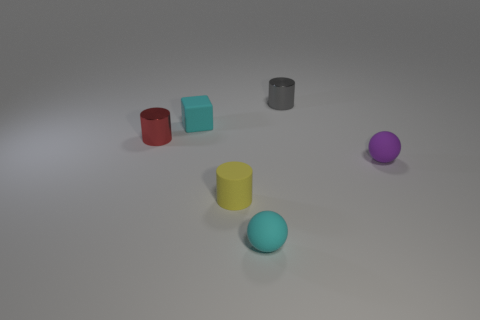Add 2 cylinders. How many objects exist? 8 Subtract all blocks. How many objects are left? 5 Add 4 big gray rubber cylinders. How many big gray rubber cylinders exist? 4 Subtract 0 gray spheres. How many objects are left? 6 Subtract all green metal things. Subtract all tiny purple matte spheres. How many objects are left? 5 Add 6 small cyan rubber spheres. How many small cyan rubber spheres are left? 7 